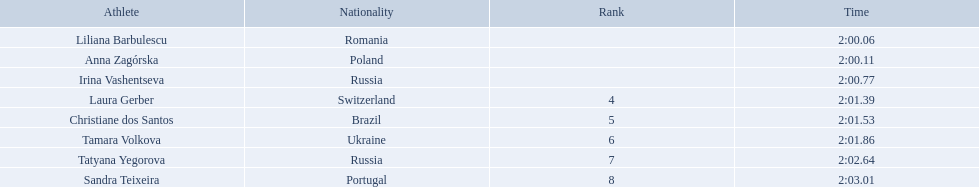What were all the finishing times? 2:00.06, 2:00.11, 2:00.77, 2:01.39, 2:01.53, 2:01.86, 2:02.64, 2:03.01. Which of these is anna zagorska's? 2:00.11. Who were the athletes? Liliana Barbulescu, 2:00.06, Anna Zagórska, 2:00.11, Irina Vashentseva, 2:00.77, Laura Gerber, 2:01.39, Christiane dos Santos, 2:01.53, Tamara Volkova, 2:01.86, Tatyana Yegorova, 2:02.64, Sandra Teixeira, 2:03.01. Who received 2nd place? Anna Zagórska, 2:00.11. What was her time? 2:00.11. Who were the athlete were in the athletics at the 2003 summer universiade - women's 800 metres? , Liliana Barbulescu, Anna Zagórska, Irina Vashentseva, Laura Gerber, Christiane dos Santos, Tamara Volkova, Tatyana Yegorova, Sandra Teixeira. What was anna zagorska finishing time? 2:00.11. 